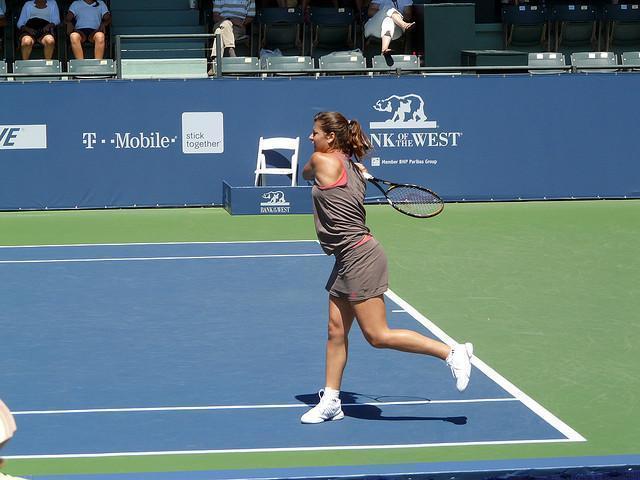What is the middle advertisement on the blue wall about?
Indicate the correct response and explain using: 'Answer: answer
Rationale: rationale.'
Options: Athletic help, banking, suicide hotline, cellular service. Answer: cellular service.
Rationale: The advertisement is for phones. 